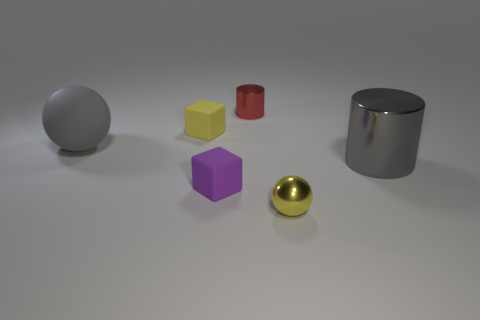Add 2 small purple objects. How many objects exist? 8 Subtract all spheres. How many objects are left? 4 Subtract all green metallic cylinders. Subtract all tiny matte objects. How many objects are left? 4 Add 4 gray spheres. How many gray spheres are left? 5 Add 2 yellow things. How many yellow things exist? 4 Subtract 0 brown cylinders. How many objects are left? 6 